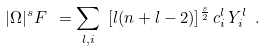Convert formula to latex. <formula><loc_0><loc_0><loc_500><loc_500>| \Omega | ^ { s } F \ = \sum _ { l , i } \ [ l ( n + l - 2 ) ] ^ { \frac { s } { 2 } } \, c ^ { l } _ { i } \, Y _ { i } ^ { l } \ .</formula> 